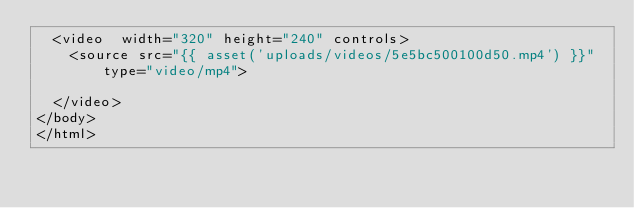Convert code to text. <code><loc_0><loc_0><loc_500><loc_500><_PHP_>	<video  width="320" height="240" controls>
		<source src="{{ asset('uploads/videos/5e5bc500100d50.mp4') }}" type="video/mp4">

	</video>
</body>
</html></code> 